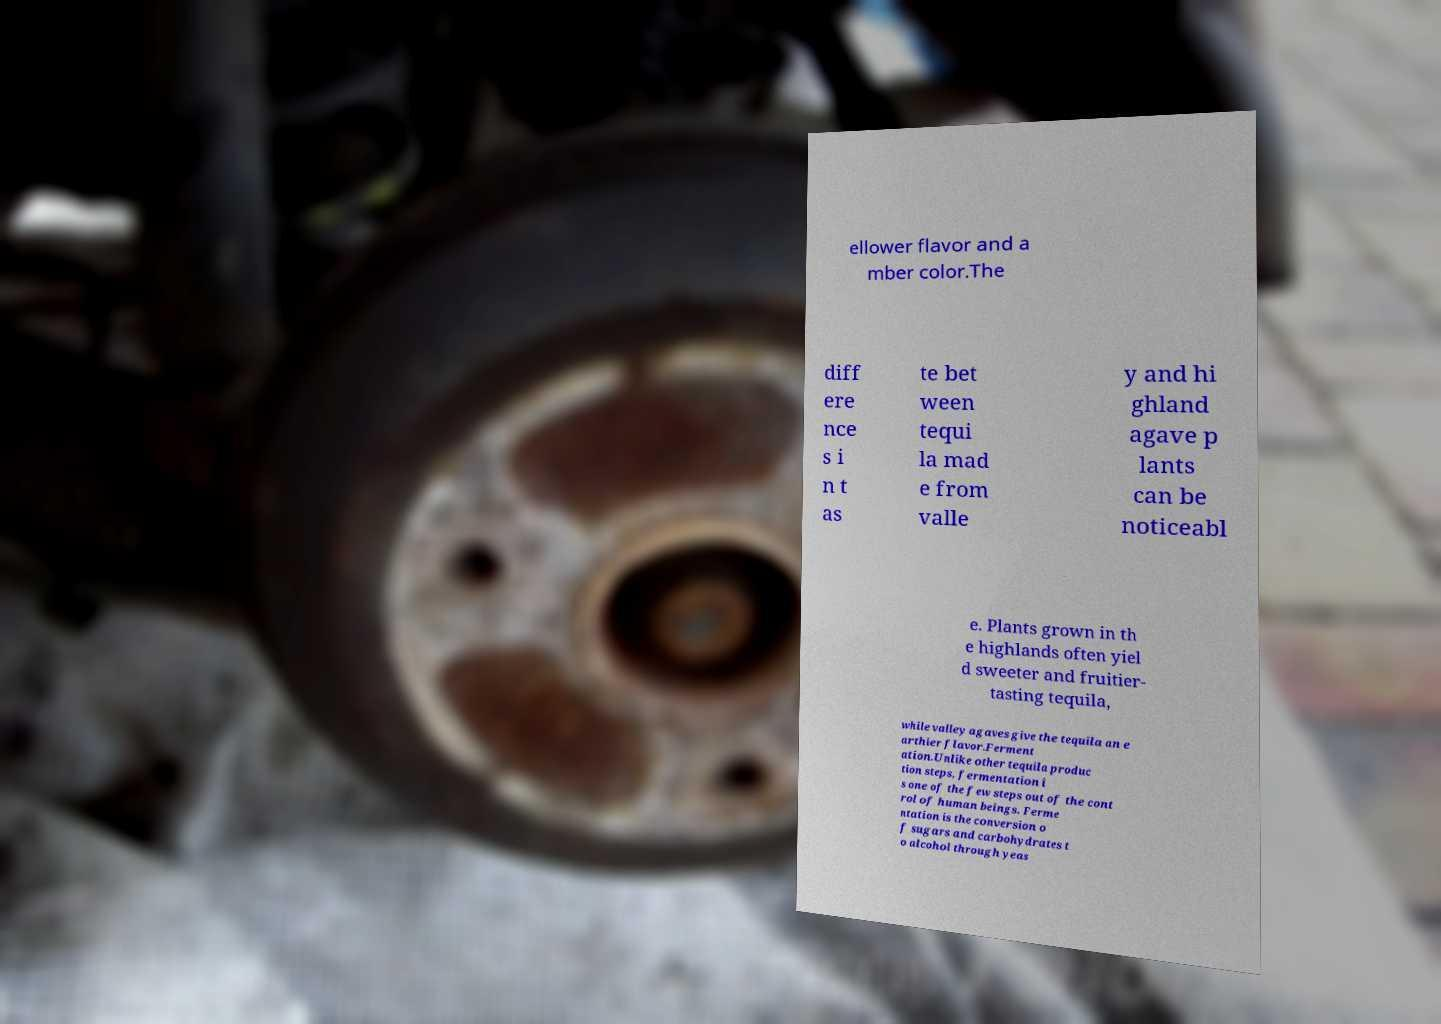For documentation purposes, I need the text within this image transcribed. Could you provide that? ellower flavor and a mber color.The diff ere nce s i n t as te bet ween tequi la mad e from valle y and hi ghland agave p lants can be noticeabl e. Plants grown in th e highlands often yiel d sweeter and fruitier- tasting tequila, while valley agaves give the tequila an e arthier flavor.Ferment ation.Unlike other tequila produc tion steps, fermentation i s one of the few steps out of the cont rol of human beings. Ferme ntation is the conversion o f sugars and carbohydrates t o alcohol through yeas 